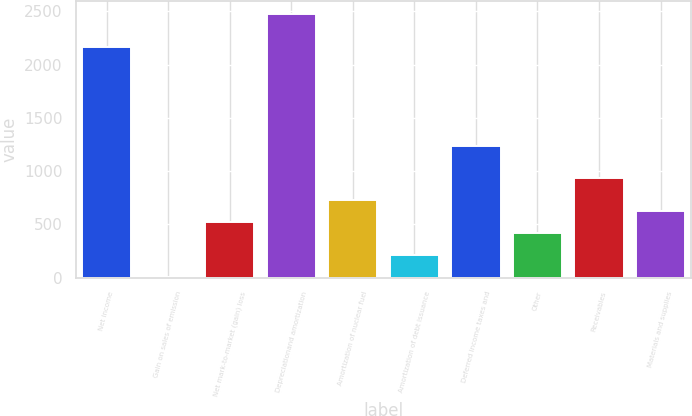<chart> <loc_0><loc_0><loc_500><loc_500><bar_chart><fcel>Net income<fcel>Gain on sales of emission<fcel>Net mark-to-market (gain) loss<fcel>Depreciationand amortization<fcel>Amortization of nuclear fuel<fcel>Amortization of debt issuance<fcel>Deferred income taxes and<fcel>Other<fcel>Receivables<fcel>Materials and supplies<nl><fcel>2163.8<fcel>5<fcel>519<fcel>2472.2<fcel>724.6<fcel>210.6<fcel>1238.6<fcel>416.2<fcel>930.2<fcel>621.8<nl></chart> 